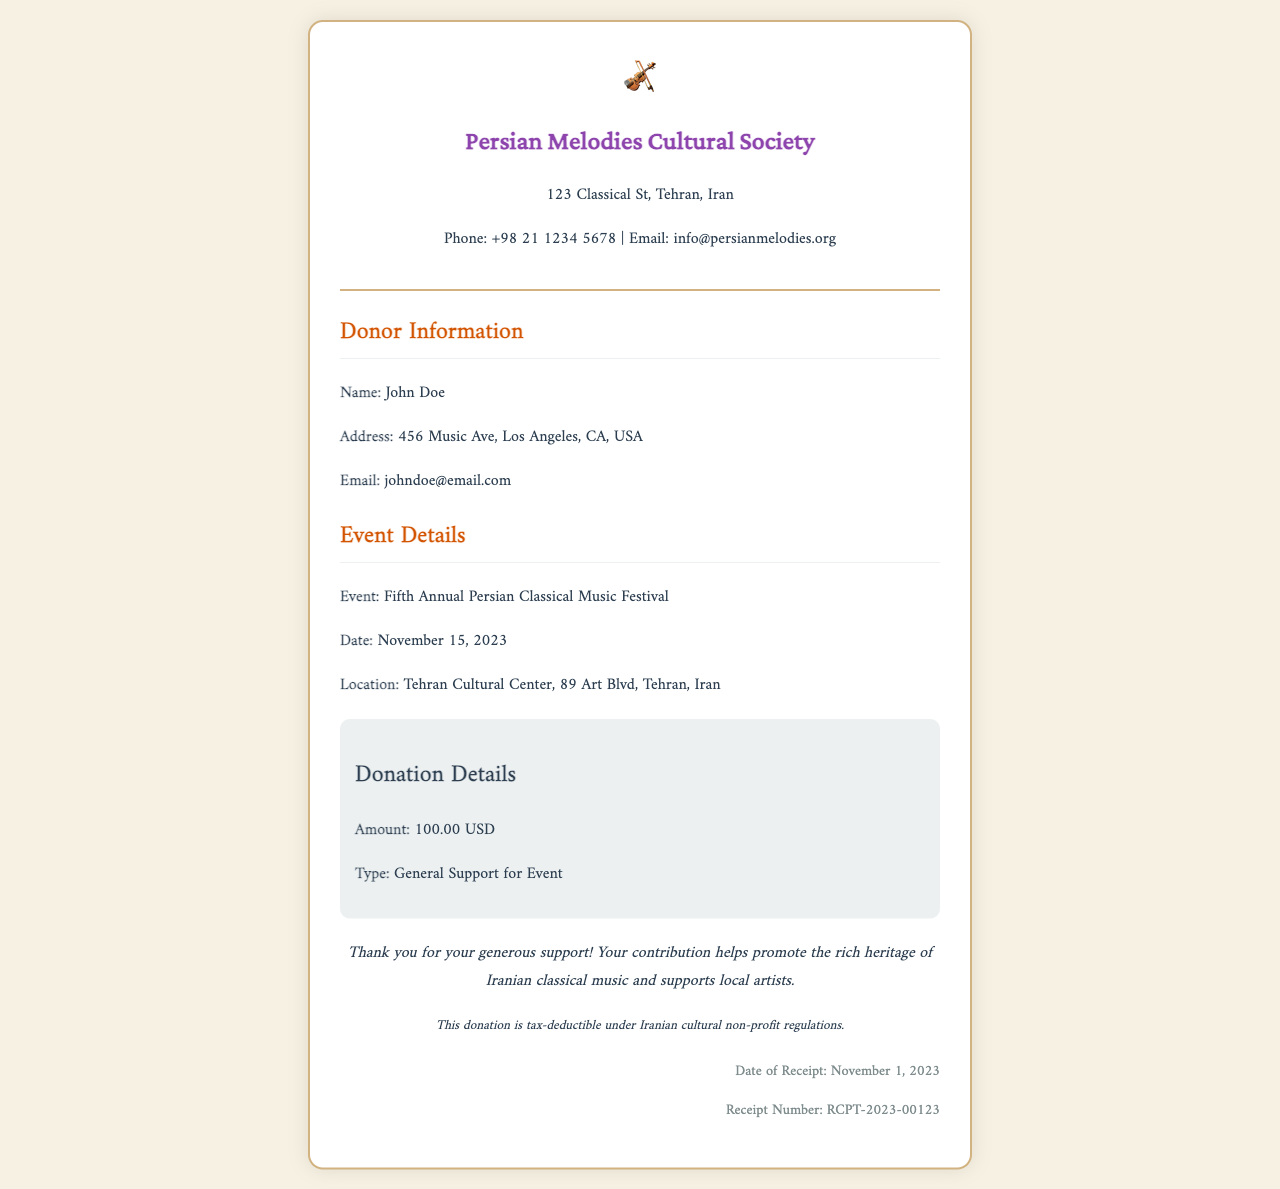what is the name of the cultural society? The name of the cultural society is mentioned in the header of the document.
Answer: Persian Melodies Cultural Society what is the event date? The date of the event is specified in the Event Details section.
Answer: November 15, 2023 who is the donor? The donor's name is found in the Donor Information section of the document.
Answer: John Doe what is the amount of the donation? The donation amount is stated in the Donation Details section.
Answer: 100.00 USD where is the event location? The event location can be found in the Event Details section of the document.
Answer: Tehran Cultural Center, 89 Art Blvd, Tehran, Iran what type of donation is mentioned? The type of donation is indicated in the Donation Details section.
Answer: General Support for Event why is the donation considered tax-deductible? The acknowledgment section specifies the reason for tax-deductibility.
Answer: Iranian cultural non-profit regulations when was the receipt issued? The date of the receipt is presented in the footer of the document.
Answer: November 1, 2023 how many annual festivals have there been? The event title in the document indicates the count of annual festivals.
Answer: Fifth Annual 